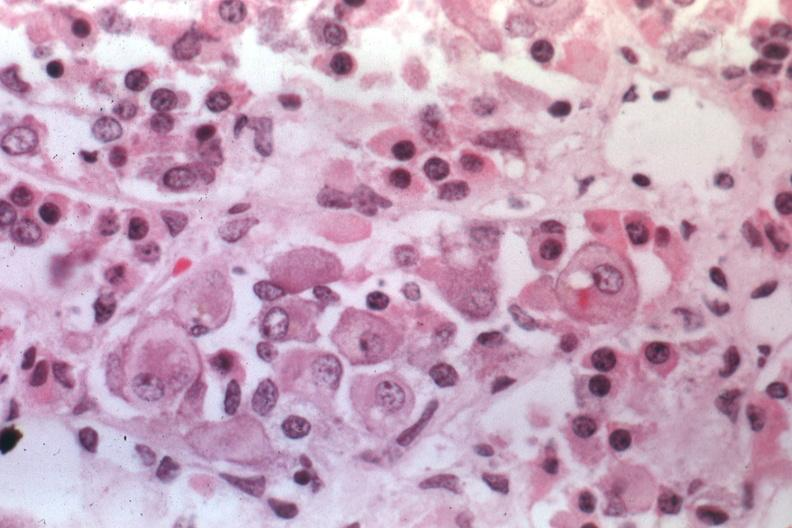s mitotic figures present?
Answer the question using a single word or phrase. No 